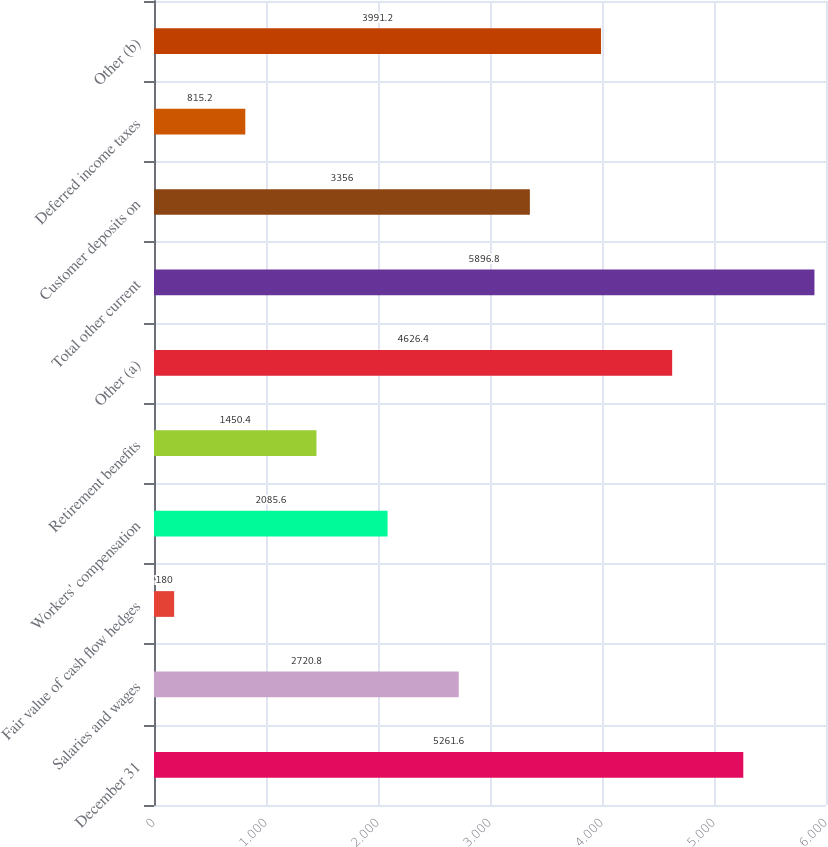Convert chart to OTSL. <chart><loc_0><loc_0><loc_500><loc_500><bar_chart><fcel>December 31<fcel>Salaries and wages<fcel>Fair value of cash flow hedges<fcel>Workers' compensation<fcel>Retirement benefits<fcel>Other (a)<fcel>Total other current<fcel>Customer deposits on<fcel>Deferred income taxes<fcel>Other (b)<nl><fcel>5261.6<fcel>2720.8<fcel>180<fcel>2085.6<fcel>1450.4<fcel>4626.4<fcel>5896.8<fcel>3356<fcel>815.2<fcel>3991.2<nl></chart> 